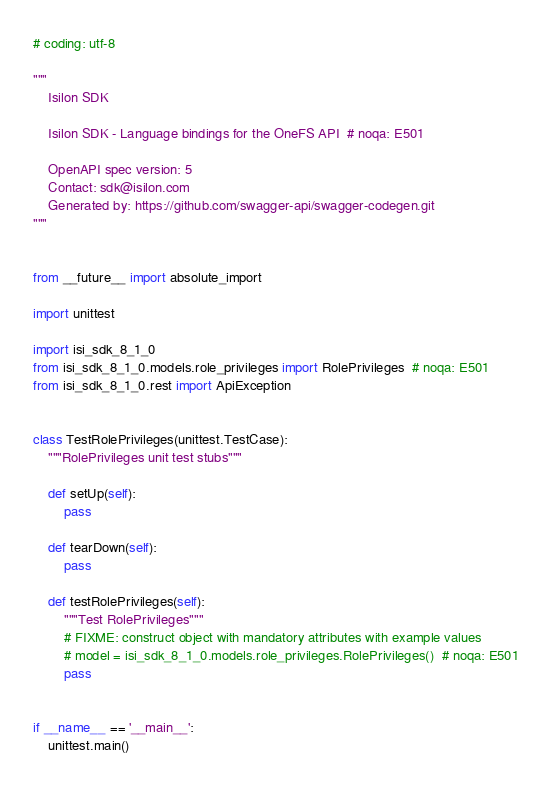Convert code to text. <code><loc_0><loc_0><loc_500><loc_500><_Python_># coding: utf-8

"""
    Isilon SDK

    Isilon SDK - Language bindings for the OneFS API  # noqa: E501

    OpenAPI spec version: 5
    Contact: sdk@isilon.com
    Generated by: https://github.com/swagger-api/swagger-codegen.git
"""


from __future__ import absolute_import

import unittest

import isi_sdk_8_1_0
from isi_sdk_8_1_0.models.role_privileges import RolePrivileges  # noqa: E501
from isi_sdk_8_1_0.rest import ApiException


class TestRolePrivileges(unittest.TestCase):
    """RolePrivileges unit test stubs"""

    def setUp(self):
        pass

    def tearDown(self):
        pass

    def testRolePrivileges(self):
        """Test RolePrivileges"""
        # FIXME: construct object with mandatory attributes with example values
        # model = isi_sdk_8_1_0.models.role_privileges.RolePrivileges()  # noqa: E501
        pass


if __name__ == '__main__':
    unittest.main()
</code> 